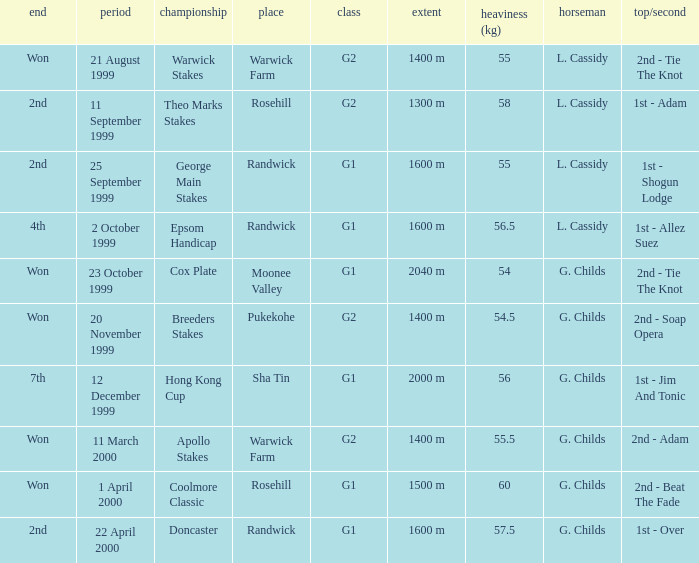List the weight for 56 kilograms. 2000 m. 